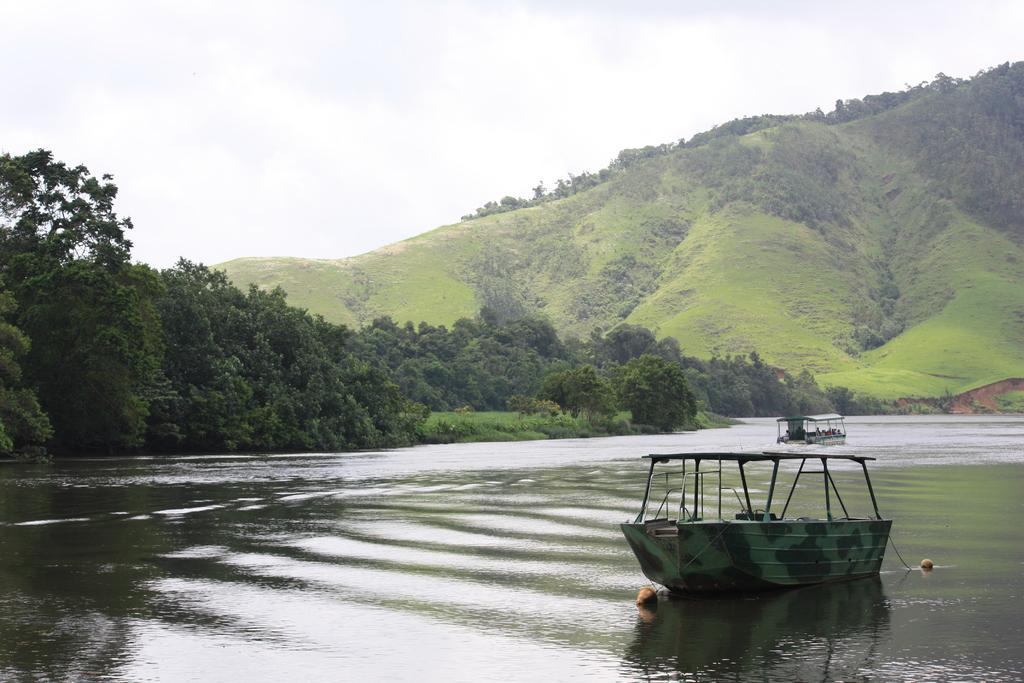How would you summarize this image in a sentence or two? In this image at the bottom there is a river, and in the river there are some boats. And in the background there are mountains, trees and plants. And at the top there is sky. 